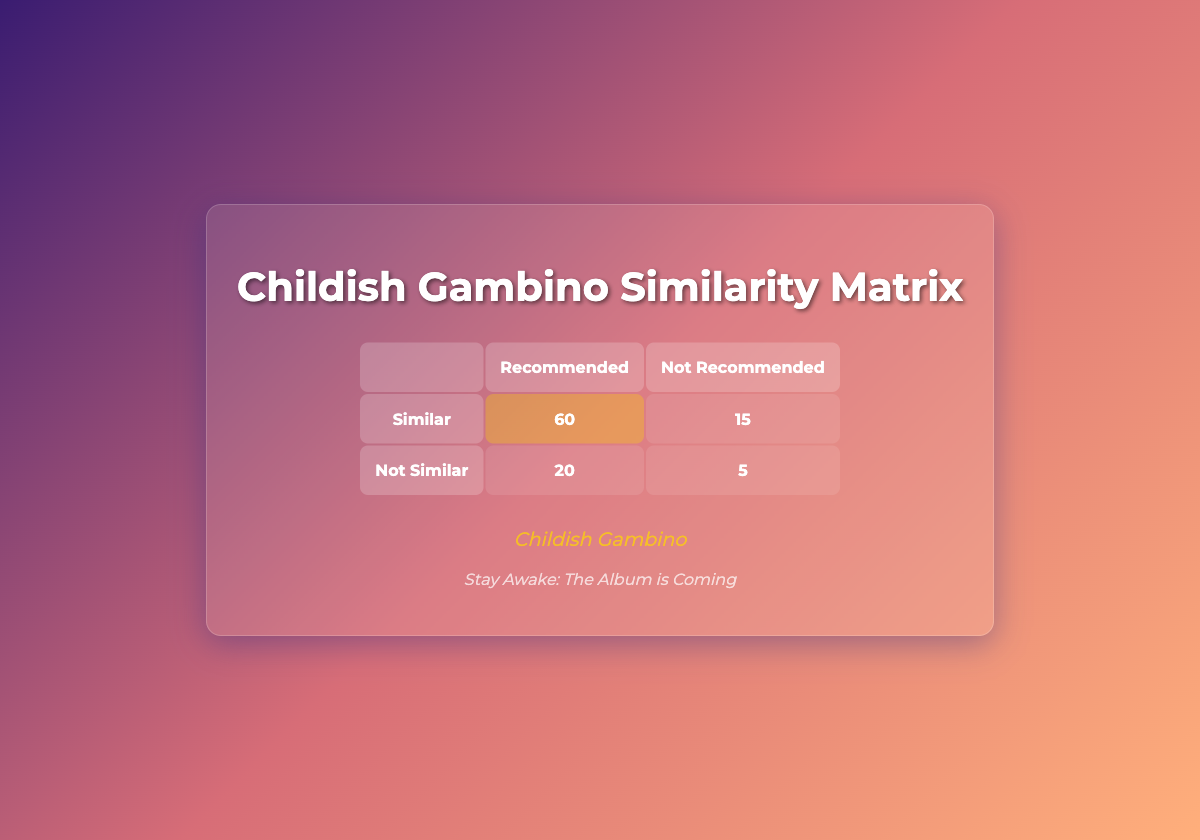What is the number of times Childish Gambino was predicted to be recommended? The table shows that the predicted similarity for Childish Gambino states that it was recommended 80 times.
Answer: 80 What is the number of instances where Childish Gambino was not recommended according to the ground truth? Looking at the ground truth data for Childish Gambino, it indicates that it was not similar 25 times.
Answer: 25 How many times were Childish Gambino and Frank Ocean predicted to be recommended together? For Childish Gambino, the predicted recommendations are 80, and for Frank Ocean, it is 65. Adding these together gives 80 + 65 = 145.
Answer: 145 What is the total number of similar and not similar predictions for Childish Gambino? The similar predictions for Childish Gambino total 75 and the not similar predictions total 25. Adding these gives 75 + 25 = 100.
Answer: 100 Is it true that the predicted recommendations for Childish Gambino exceed the number of times it was not recommended? Yes, the predicted recommendations for Childish Gambino are 80, while the not recommended count is 20, confirming that the recommendations exceed the not recommended counts.
Answer: Yes If Childish Gambino's similar predictions (75) were to be split evenly with those of SZA (65), how many would each artist get from a total of 140 predictions? If we take the total of 140 predictions, splitting evenly means dividing by the two artists, which results in each getting 70. Since SZA's actual similar predictions were 65, they received their 65 while Childish Gambino would only have 5 left.
Answer: Childish Gambino: 5; SZA: 65 What is the difference between the number of times Childish Gambino was predicted to be recommended vs. Kendrick Lamar? The predicted recommendations for Childish Gambino are 80, and for Kendrick Lamar, it is 70. The difference is 80 - 70 = 10.
Answer: 10 How many total recommendations were predicted across all artists? Adding all predicted recommendations together gives: 80 (Childish Gambino) + 65 (Frank Ocean) + 70 (Kendrick Lamar) + 68 (SZA) + 75 (Anderson .Paak) = 358.
Answer: 358 What is the probability that Childish Gambino is similar based on predicted recommendations? The predicted similarity states that Childish Gambino has 80 recommended out of 100 total predictions (80 + 20), so probability is 80/100 = 0.8 or 80%.
Answer: 80% 